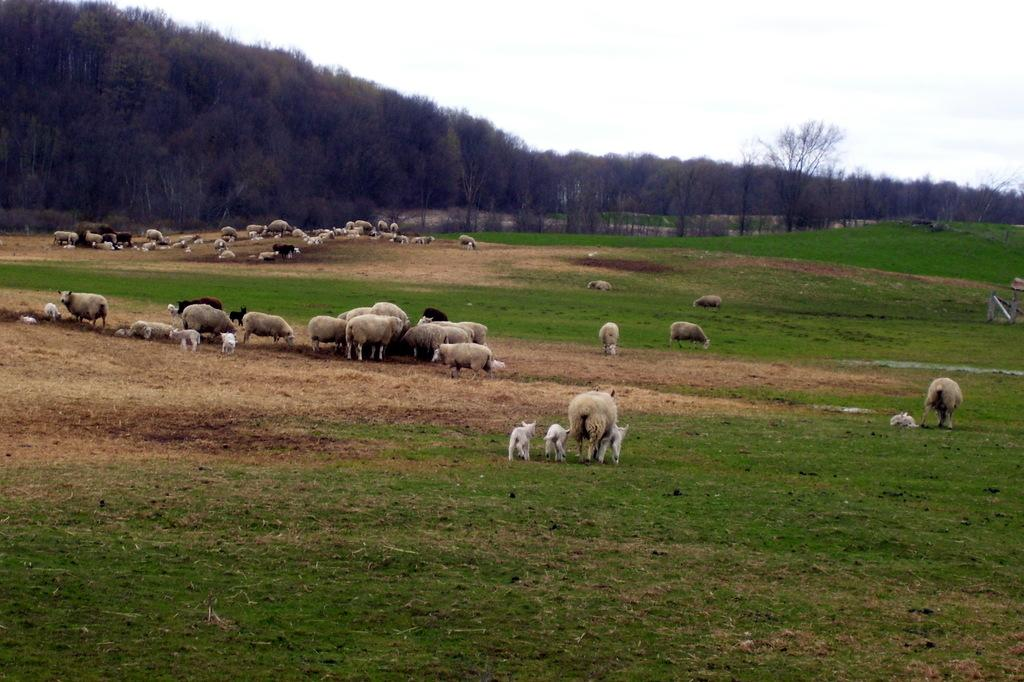What is present on the ground in the image? There is a herd on the ground in the image. What type of vegetation can be seen in the image? There is grass visible in the image. What can be seen in the background of the image? There is a group of trees in the image. How would you describe the sky in the image? The sky is visible in the image, and it appears cloudy. What type of dirt is being used to stick the birthday decorations to the trees in the image? There is no mention of a birthday or decorations in the image, and therefore no dirt or glue is present. 